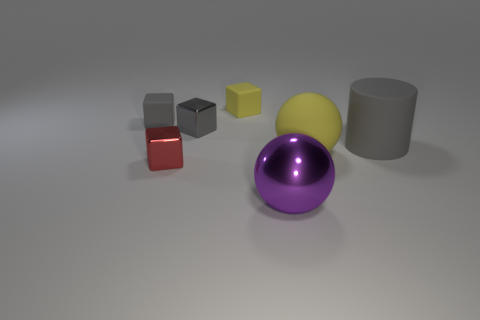Is there any other thing that has the same shape as the large gray object?
Offer a terse response. No. There is a yellow rubber object that is left of the purple sphere; how many small cubes are in front of it?
Ensure brevity in your answer.  3. Is the size of the rubber cube that is on the left side of the small gray shiny thing the same as the gray cube that is to the right of the red thing?
Offer a very short reply. Yes. What number of cyan matte cylinders are there?
Keep it short and to the point. 0. How many blocks have the same material as the purple ball?
Your answer should be very brief. 2. Is the number of tiny gray rubber objects behind the tiny yellow cube the same as the number of purple matte things?
Offer a very short reply. Yes. There is a tiny object that is the same color as the rubber ball; what is it made of?
Give a very brief answer. Rubber. There is a cylinder; is it the same size as the gray rubber object to the left of the yellow cube?
Your response must be concise. No. What number of other objects are there of the same size as the red metallic cube?
Provide a succinct answer. 3. How many other things are there of the same color as the large matte cylinder?
Provide a succinct answer. 2. 